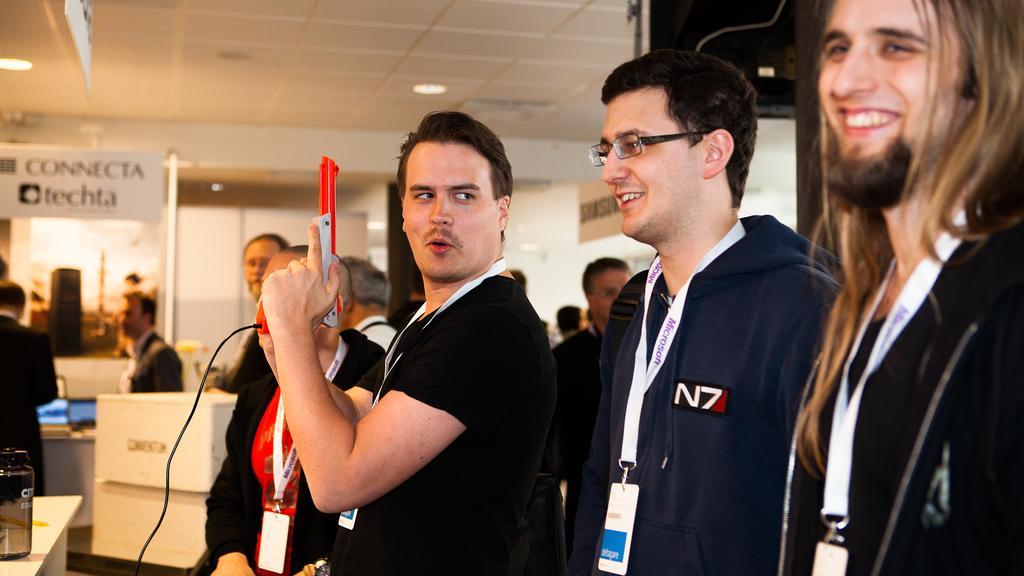In one or two sentences, can you explain what this image depicts? In this image there are group of persons truncated towards the bottom of the image, there is a person truncated towards the right of the image, there is a table truncated towards the bottom of the image, there is an object on the table, there is a person truncated towards the left of the image, there is a board truncated towards the left of the image, there is text on the board, there is an object on the ground, there is a person holding an object, there is a wire truncated towards the bottom of the image, there is wall, there is a board truncated towards the top of the image, there is a roof truncated towards the top of the image, there is an object truncated towards the top of the image, there is a wire truncated towards the top of the image, there are lights on the roof. 